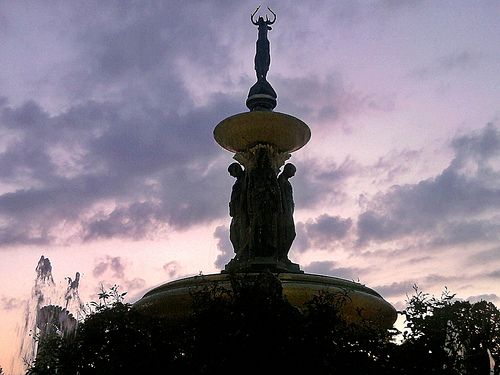<image>
Can you confirm if the fountain is on the clouds? No. The fountain is not positioned on the clouds. They may be near each other, but the fountain is not supported by or resting on top of the clouds. 